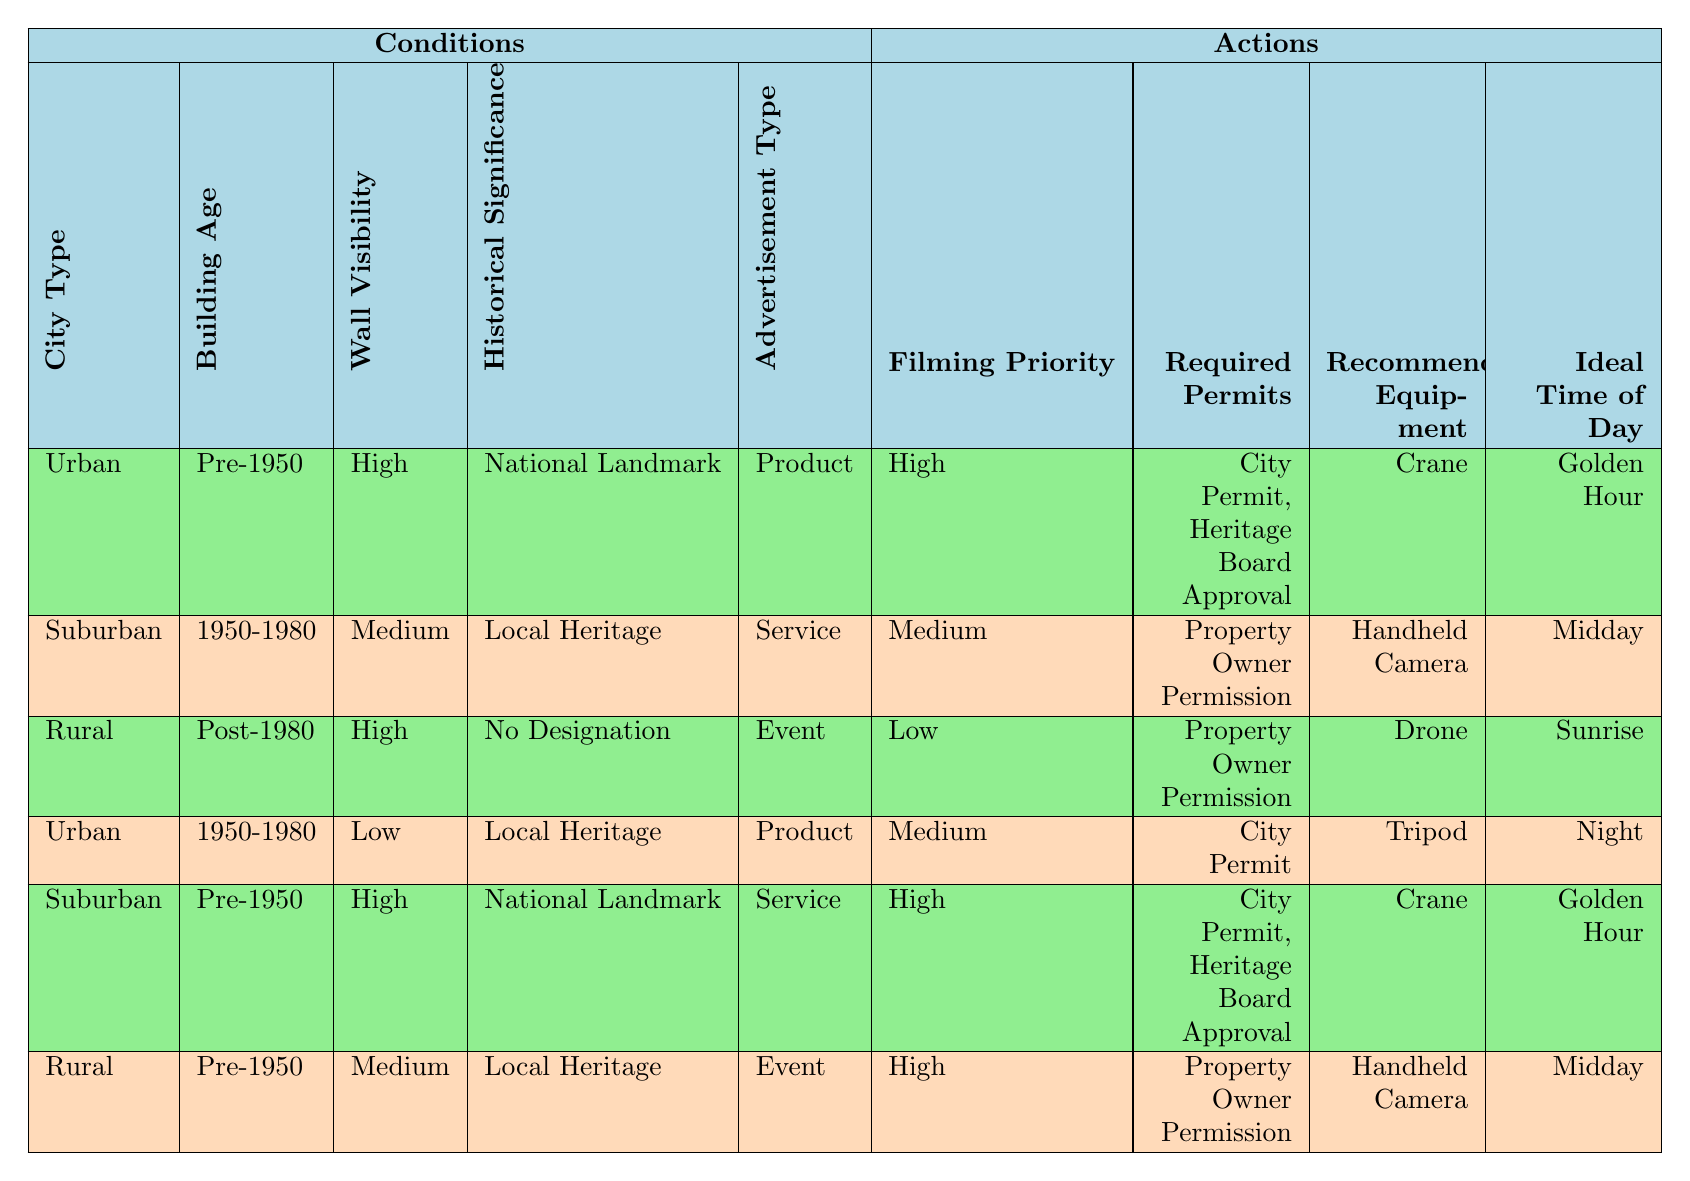What is the filming priority for hand-painted advertisements located in Urban areas with high wall visibility and a national landmark status? From the table, we see that for Urban areas with Pre-1950 buildings, high wall visibility, national landmark significance, and product advertisement type, the filming priority is marked as High.
Answer: High Which required permits are needed for filming suburban service advertisements that are in buildings constructed between 1950 and 1980? According to the table, filming in suburban areas with 1950-1980 buildings for service advertisements requires Property Owner Permission.
Answer: Property Owner Permission Is there any situation in which a filming location has a low filming priority? By examining the table, we note that in Rural areas with Post-1980 buildings for event advertisements, the filming priority is indeed rated as Low.
Answer: Yes How many filming locations are categorized with medium filming priority? Referring to the table, we find two instances: Suburban with 1950-1980 buildings, and Urban with 1950-1980 buildings that fall under medium priority. Hence, we total the instances: 2.
Answer: 2 For hand-painted advertisements in Rural areas that are Post-1980 and have no historical designation, what equipment is recommended? The table indicates that for Rural areas with Post-1980 buildings, no historical designation, and event advertisement type, the recommended equipment is a Drone.
Answer: Drone If you want to film an advertisement in a suburban area with Pre-1950 buildings that have national landmark significance for a service, what is the ideal time of day? The table reveals that for Suburban areas with Pre-1950 buildings marked as national landmarks for service advertisements, the ideal time of day to film is Golden Hour.
Answer: Golden Hour For hand-painted advertisements with a medium filming priority, what types of equipment are suggested? Looking through the table, we find that filming priority was rated as medium for two rows: one suggests Handheld Camera, while another recommends Tripod. Therefore, we can conclude the types of equipment.
Answer: Handheld Camera, Tripod Can you have low filming priority in an urban area? After reviewing the table, we observe that low filming priority does not appear for any Urban area conditions, indicating that it is not feasible.
Answer: No 